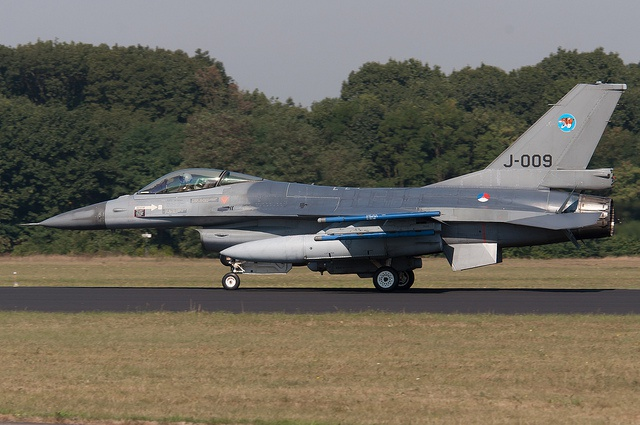Describe the objects in this image and their specific colors. I can see airplane in darkgray, black, and gray tones and people in darkgray, gray, and black tones in this image. 